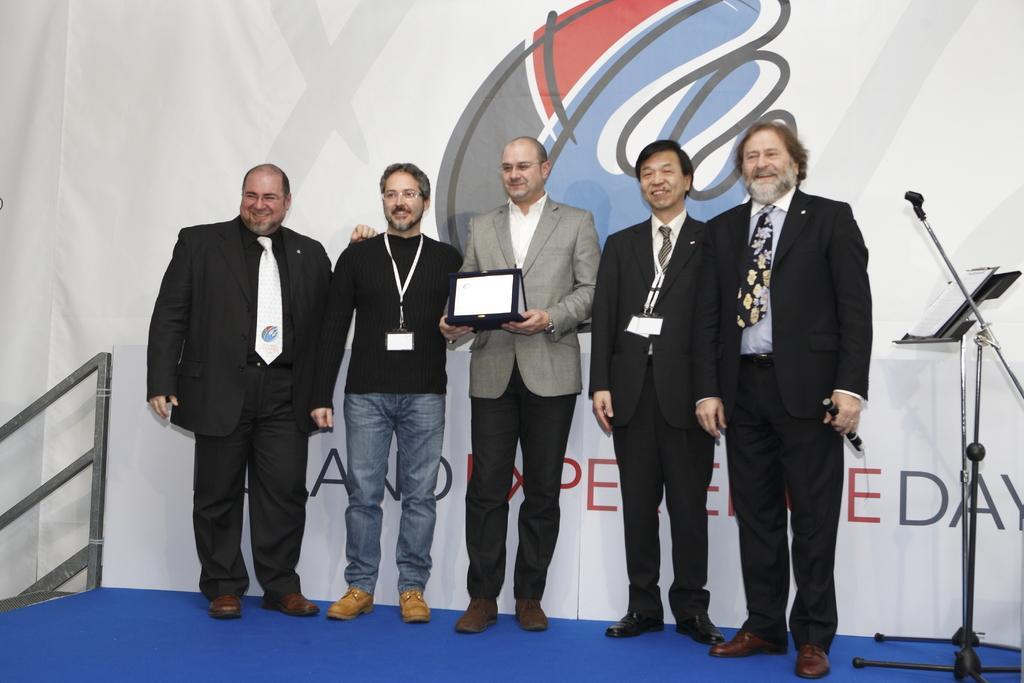Please provide a concise description of this image. In this image there are five people standing on the stage, a person holding a laptop, mike stand, book on the stand, board, iron rods. 